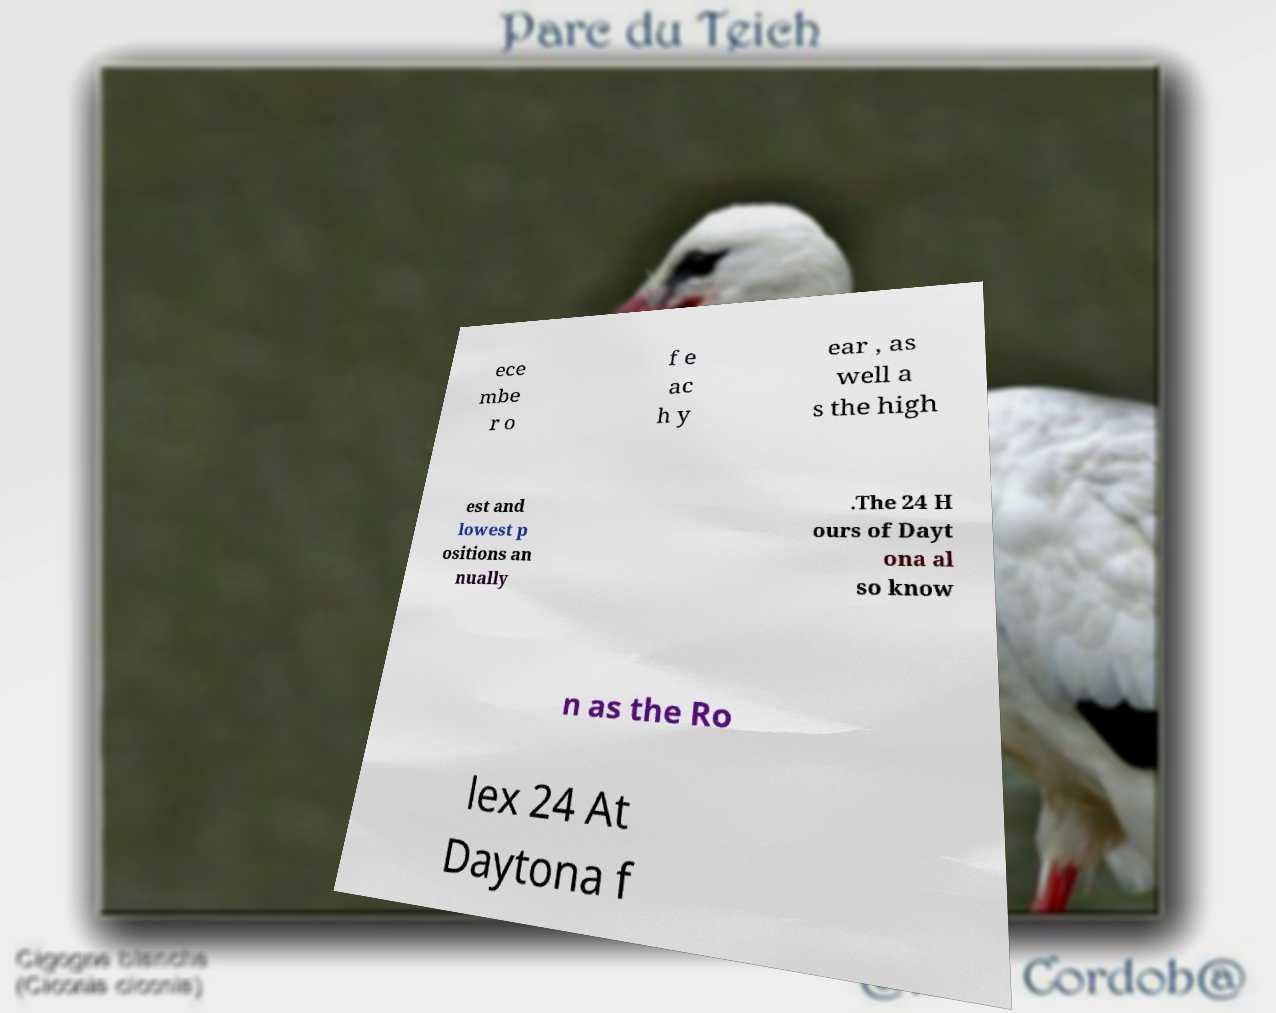There's text embedded in this image that I need extracted. Can you transcribe it verbatim? ece mbe r o f e ac h y ear , as well a s the high est and lowest p ositions an nually .The 24 H ours of Dayt ona al so know n as the Ro lex 24 At Daytona f 